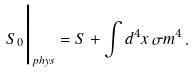<formula> <loc_0><loc_0><loc_500><loc_500>S _ { 0 } \Big | _ { p h y s } = S + \int { d ^ { 4 } x } \, \sigma m ^ { 4 } \, .</formula> 